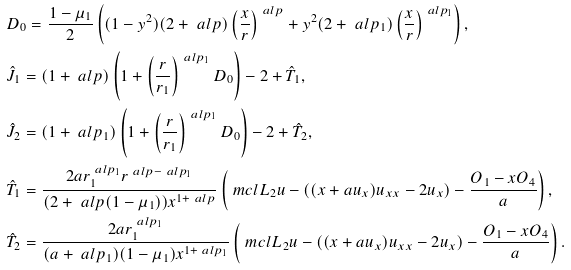Convert formula to latex. <formula><loc_0><loc_0><loc_500><loc_500>& D _ { 0 } = \frac { 1 - \mu _ { 1 } } { 2 } \left ( ( 1 - y ^ { 2 } ) ( 2 + \ a l p ) \left ( \frac { x } { r } \right ) ^ { \ a l p } + y ^ { 2 } ( 2 + \ a l p _ { 1 } ) \left ( \frac { x } { r } \right ) ^ { \ a l p _ { 1 } } \right ) , \\ & \hat { J } _ { 1 } = ( 1 + \ a l p ) \left ( 1 + \left ( \frac { r } { r _ { 1 } } \right ) ^ { \ a l p _ { 1 } } D _ { 0 } \right ) - 2 + \hat { T } _ { 1 } , \\ & \hat { J } _ { 2 } = ( 1 + \ a l p _ { 1 } ) \left ( 1 + \left ( \frac { r } { r _ { 1 } } \right ) ^ { \ a l p _ { 1 } } D _ { 0 } \right ) - 2 + \hat { T } _ { 2 } , \\ & \hat { T } _ { 1 } = \frac { 2 a r _ { 1 } ^ { \ a l p _ { 1 } } r ^ { \ a l p - \ a l p _ { 1 } } } { ( 2 + \ a l p ( 1 - \mu _ { 1 } ) ) x ^ { 1 + \ a l p } } \left ( \ m c l { L } _ { 2 } u - \left ( ( x + a u _ { x } ) u _ { x x } - 2 u _ { x } \right ) - \frac { O _ { 1 } - x O _ { 4 } } { a } \right ) , \\ & \hat { T } _ { 2 } = \frac { 2 a r _ { 1 } ^ { \ a l p _ { 1 } } } { ( a + \ a l p _ { 1 } ) ( 1 - \mu _ { 1 } ) x ^ { 1 + \ a l p _ { 1 } } } \left ( \ m c l { L } _ { 2 } u - \left ( ( x + a u _ { x } ) u _ { x x } - 2 u _ { x } \right ) - \frac { O _ { 1 } - x O _ { 4 } } { a } \right ) .</formula> 